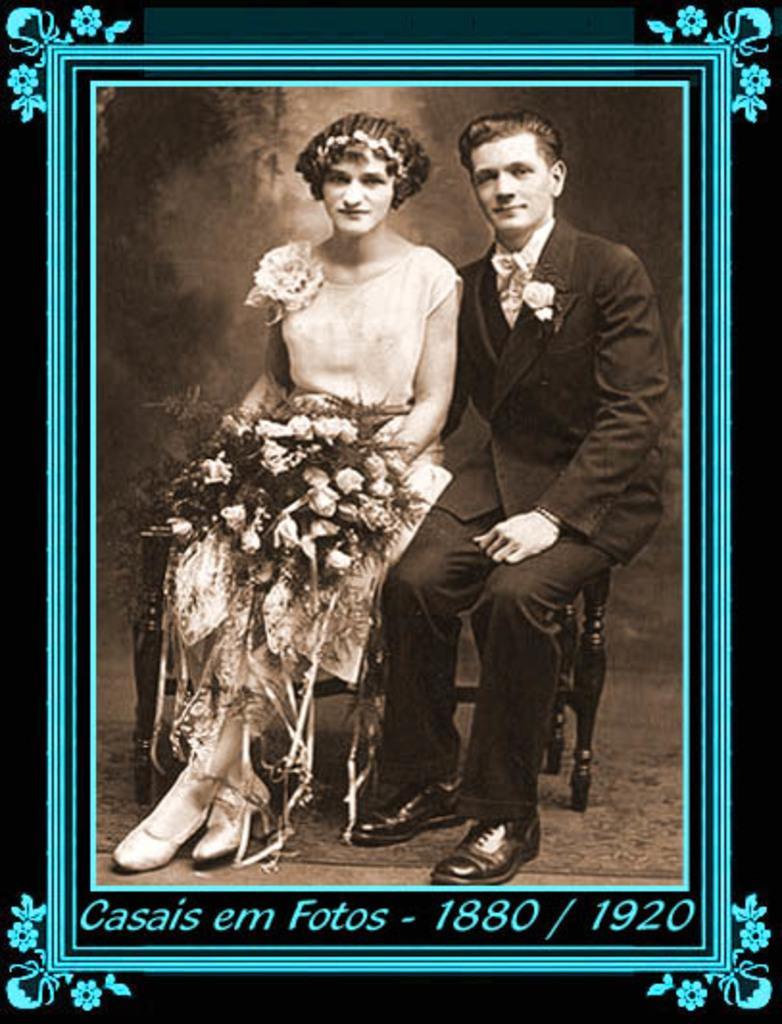Please provide a concise description of this image. This picture contains the photo frame of the man and the woman. The man in the black blazer and the woman in the white dress are sitting on the chairs. Both of them are smiling. The woman is holding a flower bouquet in her hands. In the background, it is black in color. At the bottom of the photo frame, we see some text written. 